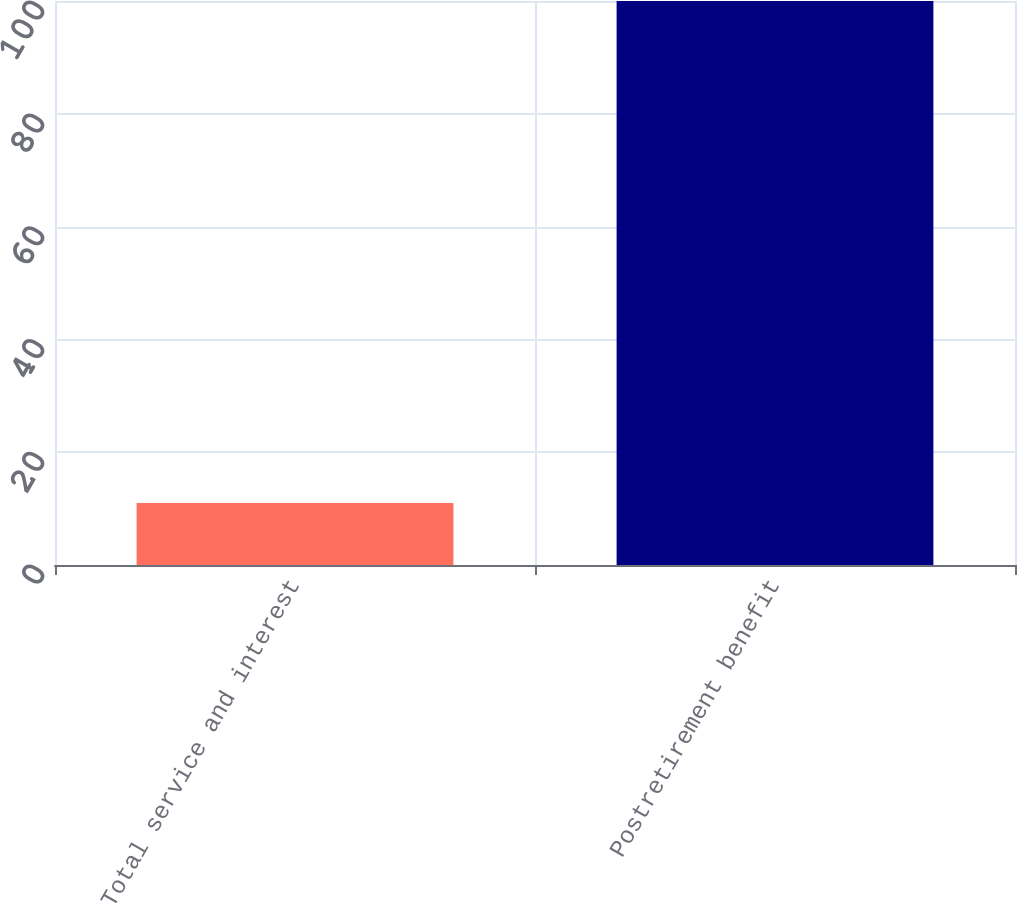<chart> <loc_0><loc_0><loc_500><loc_500><bar_chart><fcel>Total service and interest<fcel>Postretirement benefit<nl><fcel>11<fcel>100<nl></chart> 